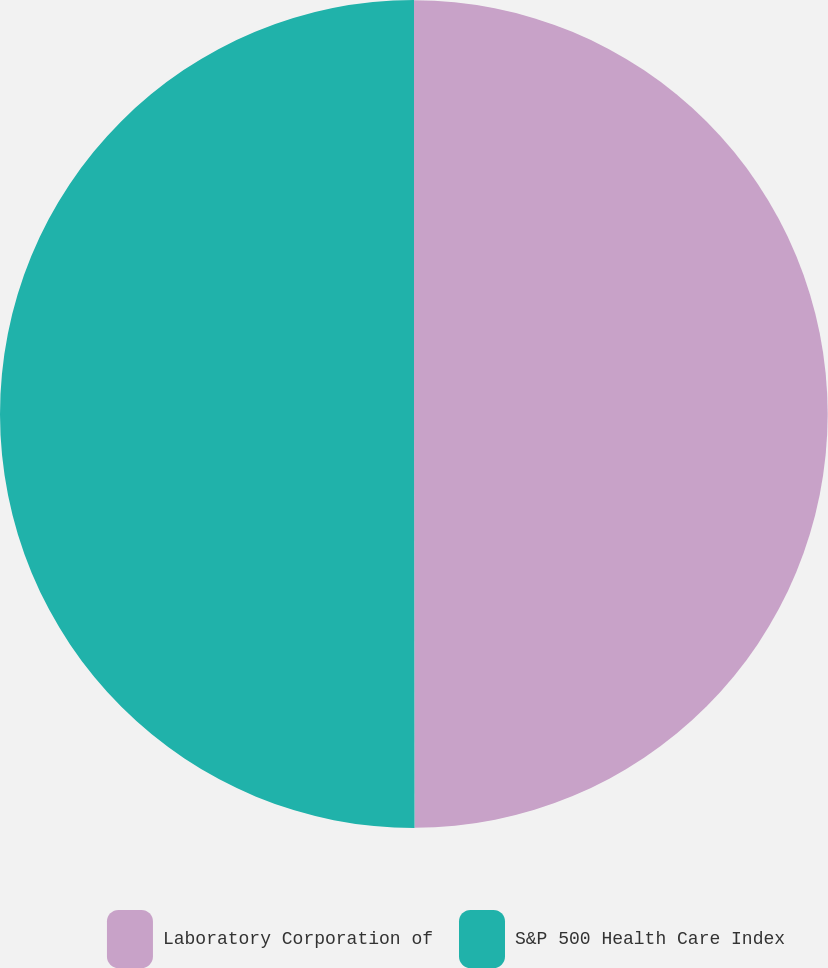Convert chart. <chart><loc_0><loc_0><loc_500><loc_500><pie_chart><fcel>Laboratory Corporation of<fcel>S&P 500 Health Care Index<nl><fcel>49.98%<fcel>50.02%<nl></chart> 